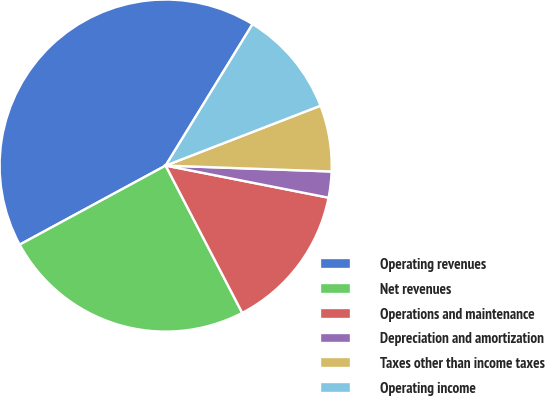Convert chart to OTSL. <chart><loc_0><loc_0><loc_500><loc_500><pie_chart><fcel>Operating revenues<fcel>Net revenues<fcel>Operations and maintenance<fcel>Depreciation and amortization<fcel>Taxes other than income taxes<fcel>Operating income<nl><fcel>41.67%<fcel>24.73%<fcel>14.27%<fcel>2.53%<fcel>6.44%<fcel>10.36%<nl></chart> 